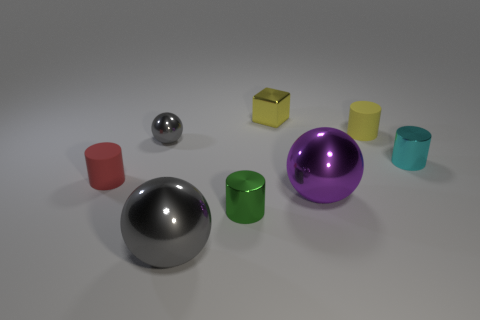Add 1 big spheres. How many objects exist? 9 Subtract all tiny balls. How many balls are left? 2 Subtract all purple cylinders. How many gray balls are left? 2 Subtract all cubes. How many objects are left? 7 Add 2 tiny red cylinders. How many tiny red cylinders exist? 3 Subtract all green cylinders. How many cylinders are left? 3 Subtract 0 blue blocks. How many objects are left? 8 Subtract 1 cubes. How many cubes are left? 0 Subtract all green balls. Subtract all blue blocks. How many balls are left? 3 Subtract all small purple metal cylinders. Subtract all big purple metallic balls. How many objects are left? 7 